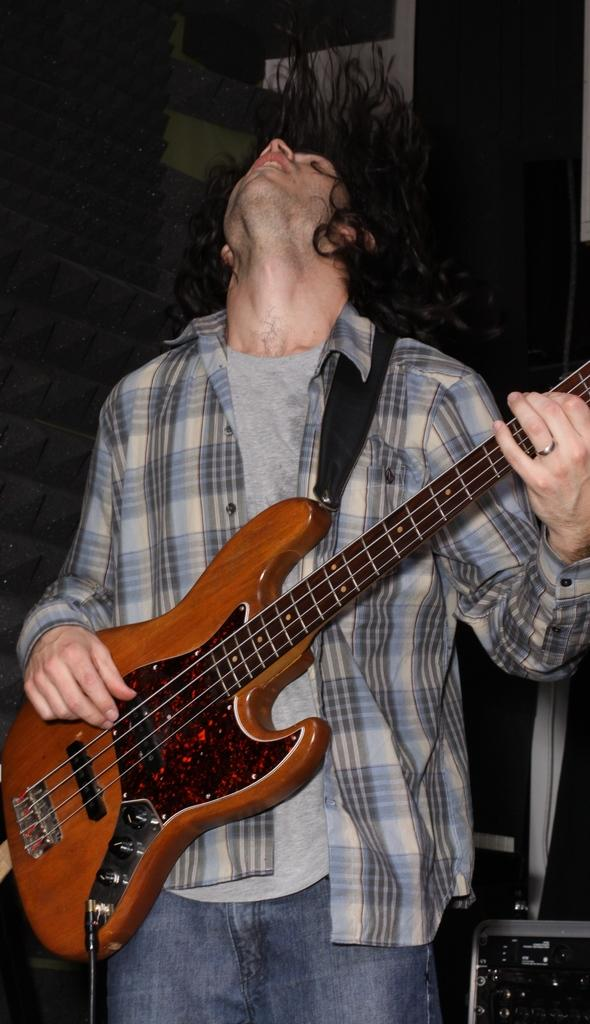What is the man in the image doing? The man is playing a guitar. How is the guitar being used in the image? The guitar is in the man's hands. What can be seen in the background of the image? There is a wall in the background of the image. Can you see any airports in the image? There is no airport visible in the image. Is the man experiencing any feelings of shame in the image? There is no indication of the man's emotions in the image, so it cannot be determined if he is experiencing any feelings of shame. 